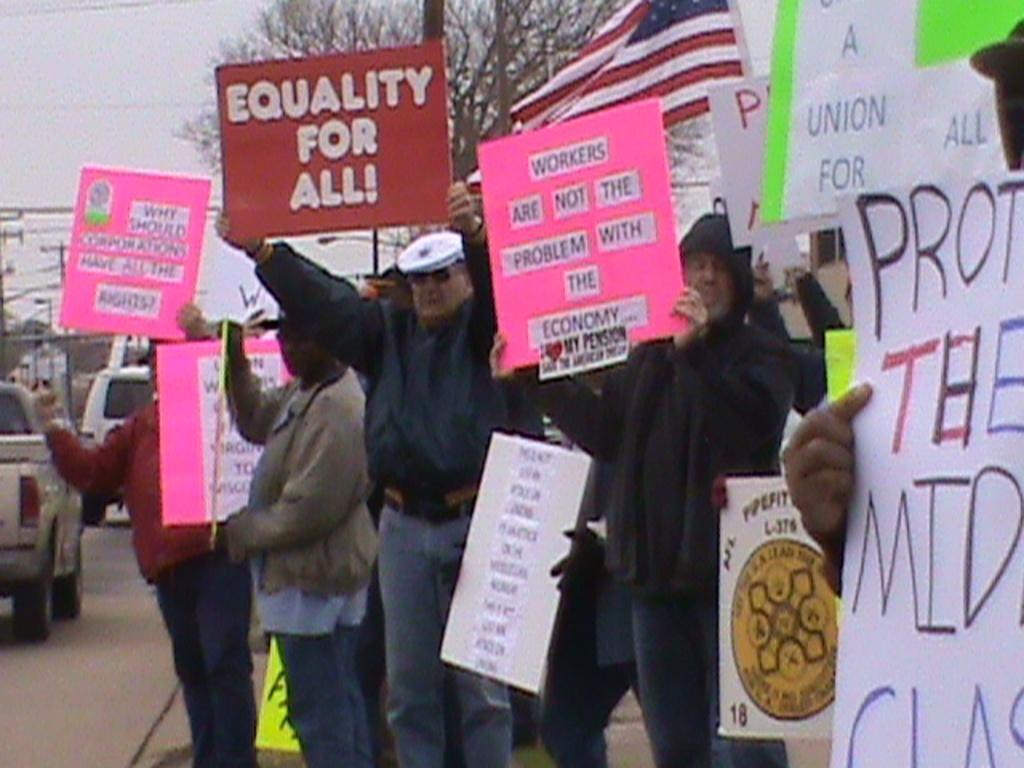Could you give a brief overview of what you see in this image? In the image in the center, we can see a few people are standing and holding banners. And we can see a few vehicles on the road. In the background we can see the sky, trees, poles and one flag. 